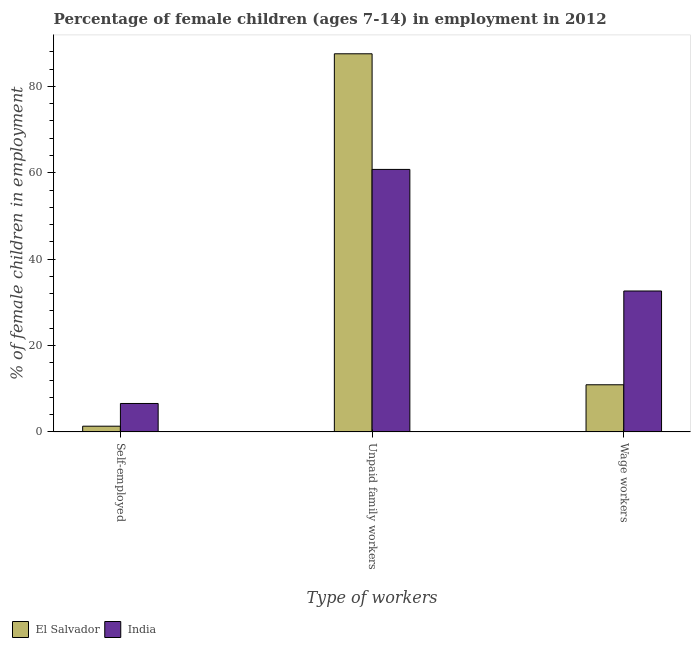How many groups of bars are there?
Offer a terse response. 3. Are the number of bars on each tick of the X-axis equal?
Give a very brief answer. Yes. How many bars are there on the 1st tick from the left?
Ensure brevity in your answer.  2. How many bars are there on the 2nd tick from the right?
Your answer should be compact. 2. What is the label of the 3rd group of bars from the left?
Provide a succinct answer. Wage workers. What is the percentage of children employed as wage workers in El Salvador?
Your answer should be compact. 10.92. Across all countries, what is the maximum percentage of self employed children?
Offer a terse response. 6.59. Across all countries, what is the minimum percentage of children employed as wage workers?
Keep it short and to the point. 10.92. In which country was the percentage of children employed as unpaid family workers minimum?
Ensure brevity in your answer.  India. What is the total percentage of self employed children in the graph?
Your answer should be compact. 7.92. What is the difference between the percentage of self employed children in El Salvador and that in India?
Give a very brief answer. -5.26. What is the difference between the percentage of children employed as unpaid family workers in El Salvador and the percentage of children employed as wage workers in India?
Your answer should be very brief. 54.92. What is the average percentage of children employed as wage workers per country?
Give a very brief answer. 21.78. What is the difference between the percentage of self employed children and percentage of children employed as unpaid family workers in India?
Your answer should be very brief. -54.19. What is the ratio of the percentage of self employed children in India to that in El Salvador?
Provide a short and direct response. 4.95. Is the percentage of children employed as unpaid family workers in India less than that in El Salvador?
Give a very brief answer. Yes. Is the difference between the percentage of children employed as unpaid family workers in India and El Salvador greater than the difference between the percentage of children employed as wage workers in India and El Salvador?
Provide a short and direct response. No. What is the difference between the highest and the second highest percentage of self employed children?
Provide a succinct answer. 5.26. What is the difference between the highest and the lowest percentage of children employed as unpaid family workers?
Ensure brevity in your answer.  26.77. Is the sum of the percentage of children employed as wage workers in El Salvador and India greater than the maximum percentage of children employed as unpaid family workers across all countries?
Your answer should be very brief. No. What does the 1st bar from the left in Wage workers represents?
Your answer should be compact. El Salvador. What does the 2nd bar from the right in Unpaid family workers represents?
Your response must be concise. El Salvador. Is it the case that in every country, the sum of the percentage of self employed children and percentage of children employed as unpaid family workers is greater than the percentage of children employed as wage workers?
Ensure brevity in your answer.  Yes. Are all the bars in the graph horizontal?
Your response must be concise. No. What is the difference between two consecutive major ticks on the Y-axis?
Your answer should be very brief. 20. Are the values on the major ticks of Y-axis written in scientific E-notation?
Keep it short and to the point. No. Does the graph contain grids?
Offer a terse response. No. How many legend labels are there?
Make the answer very short. 2. How are the legend labels stacked?
Ensure brevity in your answer.  Horizontal. What is the title of the graph?
Provide a short and direct response. Percentage of female children (ages 7-14) in employment in 2012. Does "Jamaica" appear as one of the legend labels in the graph?
Offer a terse response. No. What is the label or title of the X-axis?
Your answer should be compact. Type of workers. What is the label or title of the Y-axis?
Your response must be concise. % of female children in employment. What is the % of female children in employment of El Salvador in Self-employed?
Your answer should be very brief. 1.33. What is the % of female children in employment of India in Self-employed?
Your answer should be compact. 6.59. What is the % of female children in employment in El Salvador in Unpaid family workers?
Offer a very short reply. 87.55. What is the % of female children in employment of India in Unpaid family workers?
Your response must be concise. 60.78. What is the % of female children in employment in El Salvador in Wage workers?
Provide a short and direct response. 10.92. What is the % of female children in employment in India in Wage workers?
Keep it short and to the point. 32.63. Across all Type of workers, what is the maximum % of female children in employment in El Salvador?
Your answer should be very brief. 87.55. Across all Type of workers, what is the maximum % of female children in employment of India?
Offer a terse response. 60.78. Across all Type of workers, what is the minimum % of female children in employment of El Salvador?
Offer a very short reply. 1.33. Across all Type of workers, what is the minimum % of female children in employment of India?
Provide a succinct answer. 6.59. What is the total % of female children in employment of El Salvador in the graph?
Give a very brief answer. 99.8. What is the difference between the % of female children in employment of El Salvador in Self-employed and that in Unpaid family workers?
Ensure brevity in your answer.  -86.22. What is the difference between the % of female children in employment of India in Self-employed and that in Unpaid family workers?
Your answer should be compact. -54.19. What is the difference between the % of female children in employment of El Salvador in Self-employed and that in Wage workers?
Give a very brief answer. -9.59. What is the difference between the % of female children in employment in India in Self-employed and that in Wage workers?
Keep it short and to the point. -26.04. What is the difference between the % of female children in employment of El Salvador in Unpaid family workers and that in Wage workers?
Your answer should be very brief. 76.63. What is the difference between the % of female children in employment of India in Unpaid family workers and that in Wage workers?
Ensure brevity in your answer.  28.15. What is the difference between the % of female children in employment of El Salvador in Self-employed and the % of female children in employment of India in Unpaid family workers?
Offer a terse response. -59.45. What is the difference between the % of female children in employment in El Salvador in Self-employed and the % of female children in employment in India in Wage workers?
Your answer should be compact. -31.3. What is the difference between the % of female children in employment of El Salvador in Unpaid family workers and the % of female children in employment of India in Wage workers?
Ensure brevity in your answer.  54.92. What is the average % of female children in employment of El Salvador per Type of workers?
Provide a succinct answer. 33.27. What is the average % of female children in employment in India per Type of workers?
Keep it short and to the point. 33.33. What is the difference between the % of female children in employment of El Salvador and % of female children in employment of India in Self-employed?
Your answer should be very brief. -5.26. What is the difference between the % of female children in employment in El Salvador and % of female children in employment in India in Unpaid family workers?
Your response must be concise. 26.77. What is the difference between the % of female children in employment of El Salvador and % of female children in employment of India in Wage workers?
Provide a succinct answer. -21.71. What is the ratio of the % of female children in employment of El Salvador in Self-employed to that in Unpaid family workers?
Provide a succinct answer. 0.02. What is the ratio of the % of female children in employment in India in Self-employed to that in Unpaid family workers?
Offer a very short reply. 0.11. What is the ratio of the % of female children in employment of El Salvador in Self-employed to that in Wage workers?
Offer a very short reply. 0.12. What is the ratio of the % of female children in employment of India in Self-employed to that in Wage workers?
Offer a very short reply. 0.2. What is the ratio of the % of female children in employment in El Salvador in Unpaid family workers to that in Wage workers?
Your answer should be very brief. 8.02. What is the ratio of the % of female children in employment of India in Unpaid family workers to that in Wage workers?
Your response must be concise. 1.86. What is the difference between the highest and the second highest % of female children in employment of El Salvador?
Provide a succinct answer. 76.63. What is the difference between the highest and the second highest % of female children in employment in India?
Give a very brief answer. 28.15. What is the difference between the highest and the lowest % of female children in employment in El Salvador?
Provide a short and direct response. 86.22. What is the difference between the highest and the lowest % of female children in employment of India?
Offer a very short reply. 54.19. 